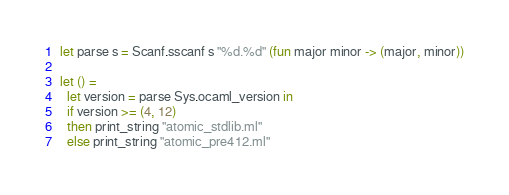<code> <loc_0><loc_0><loc_500><loc_500><_OCaml_>let parse s = Scanf.sscanf s "%d.%d" (fun major minor -> (major, minor))

let () =
  let version = parse Sys.ocaml_version in
  if version >= (4, 12)
  then print_string "atomic_stdlib.ml"
  else print_string "atomic_pre412.ml"
</code> 